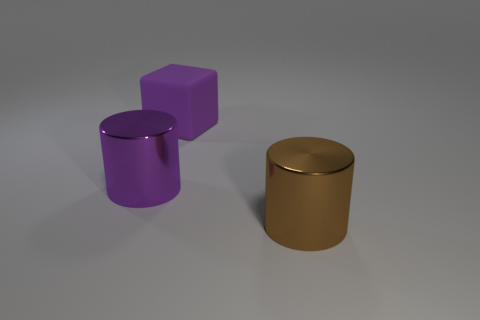Add 2 shiny things. How many objects exist? 5 Subtract all cylinders. How many objects are left? 1 Subtract 0 red blocks. How many objects are left? 3 Subtract all big purple rubber blocks. Subtract all large purple blocks. How many objects are left? 1 Add 2 matte objects. How many matte objects are left? 3 Add 1 purple shiny things. How many purple shiny things exist? 2 